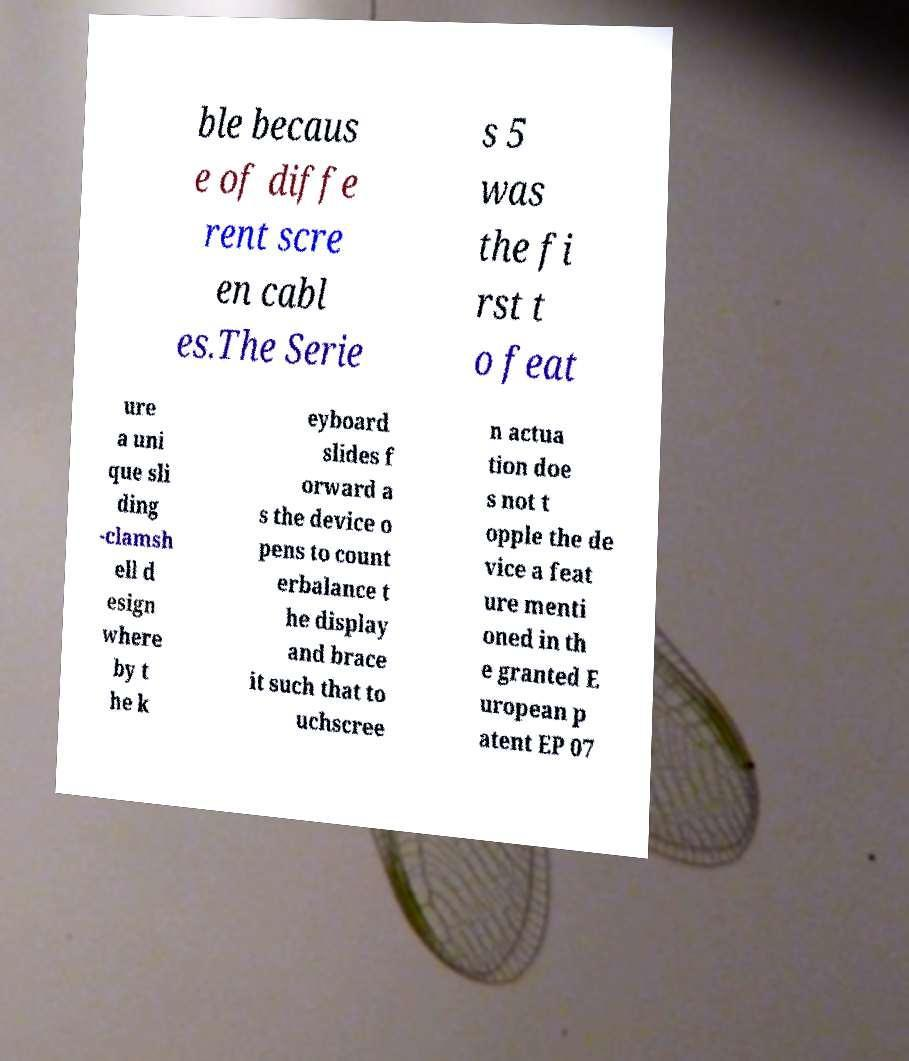What messages or text are displayed in this image? I need them in a readable, typed format. ble becaus e of diffe rent scre en cabl es.The Serie s 5 was the fi rst t o feat ure a uni que sli ding -clamsh ell d esign where by t he k eyboard slides f orward a s the device o pens to count erbalance t he display and brace it such that to uchscree n actua tion doe s not t opple the de vice a feat ure menti oned in th e granted E uropean p atent EP 07 